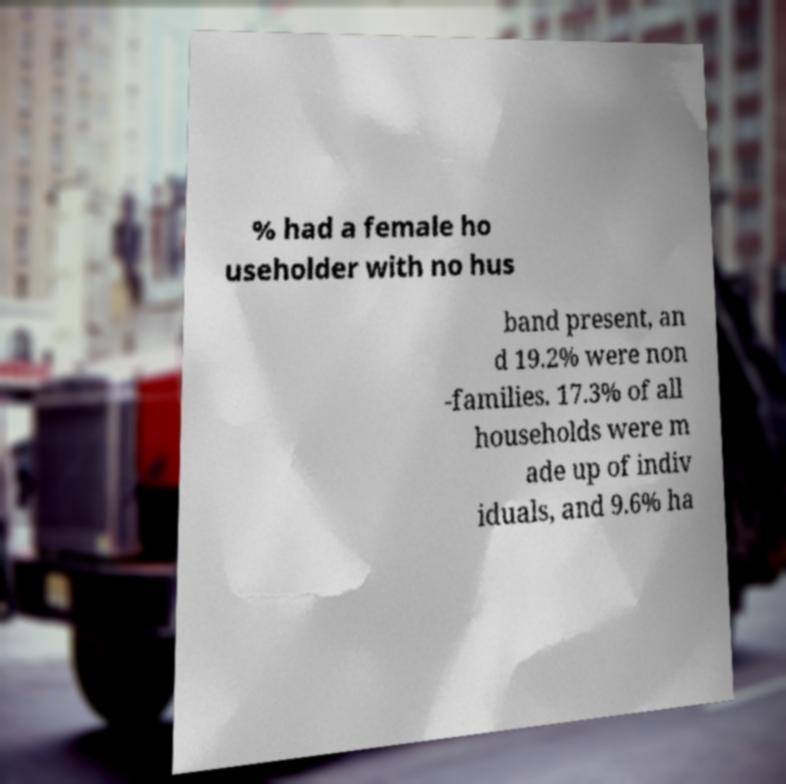Please read and relay the text visible in this image. What does it say? % had a female ho useholder with no hus band present, an d 19.2% were non -families. 17.3% of all households were m ade up of indiv iduals, and 9.6% ha 